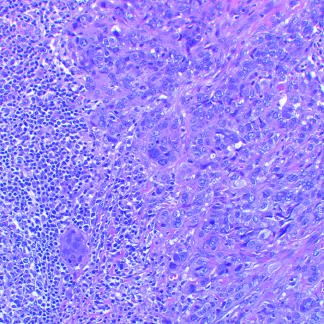what consists of tightly adhesive clusters of cells, as in this carcinoma with medullary features, or when there is abundant extracellular mucin production?
Answer the question using a single word or phrase. Carcinomas 